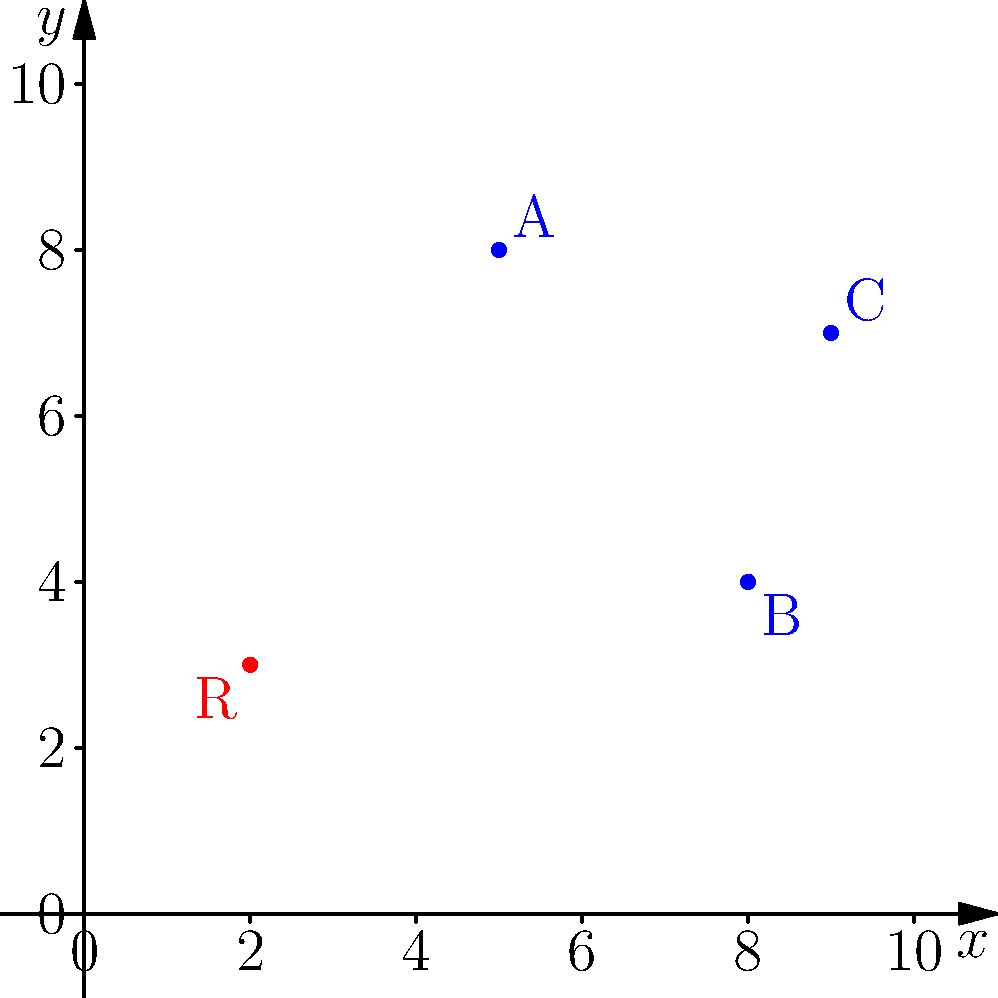Your restaurant (R) at coordinates (2,3) needs to make deliveries to three customers: A(5,8), B(8,4), and C(9,7). To minimize fuel costs, you want to find the shortest route that visits all customers and returns to the restaurant. What is the total distance of this optimal route, rounded to the nearest whole number? To solve this problem, we need to calculate the distances between all points and find the shortest route. Let's follow these steps:

1) Calculate distances between all points using the distance formula: 
   $d = \sqrt{(x_2-x_1)^2 + (y_2-y_1)^2}$

   R to A: $\sqrt{(5-2)^2 + (8-3)^2} = \sqrt{34} \approx 5.83$
   R to B: $\sqrt{(8-2)^2 + (4-3)^2} = \sqrt{37} \approx 6.08$
   R to C: $\sqrt{(9-2)^2 + (7-3)^2} = \sqrt{85} \approx 9.22$
   A to B: $\sqrt{(8-5)^2 + (4-8)^2} = \sqrt{25} = 5$
   A to C: $\sqrt{(9-5)^2 + (7-8)^2} = \sqrt{17} \approx 4.12$
   B to C: $\sqrt{(9-8)^2 + (7-4)^2} = \sqrt{10} \approx 3.16$

2) The problem is essentially the Traveling Salesman Problem. For 4 points, we can check all possible routes:

   R-A-B-C-R: 5.83 + 5 + 3.16 + 9.22 = 23.21
   R-A-C-B-R: 5.83 + 4.12 + 3.16 + 6.08 = 19.19
   R-B-A-C-R: 6.08 + 5 + 4.12 + 9.22 = 24.42
   R-B-C-A-R: 6.08 + 3.16 + 4.12 + 5.83 = 19.19
   R-C-A-B-R: 9.22 + 4.12 + 5 + 6.08 = 24.42
   R-C-B-A-R: 9.22 + 3.16 + 5 + 5.83 = 23.21

3) The shortest routes are R-A-C-B-R and R-B-C-A-R, both with a total distance of 19.19.

4) Rounding to the nearest whole number: 19.19 ≈ 19

Therefore, the optimal route has a total distance of 19 units.
Answer: 19 units 